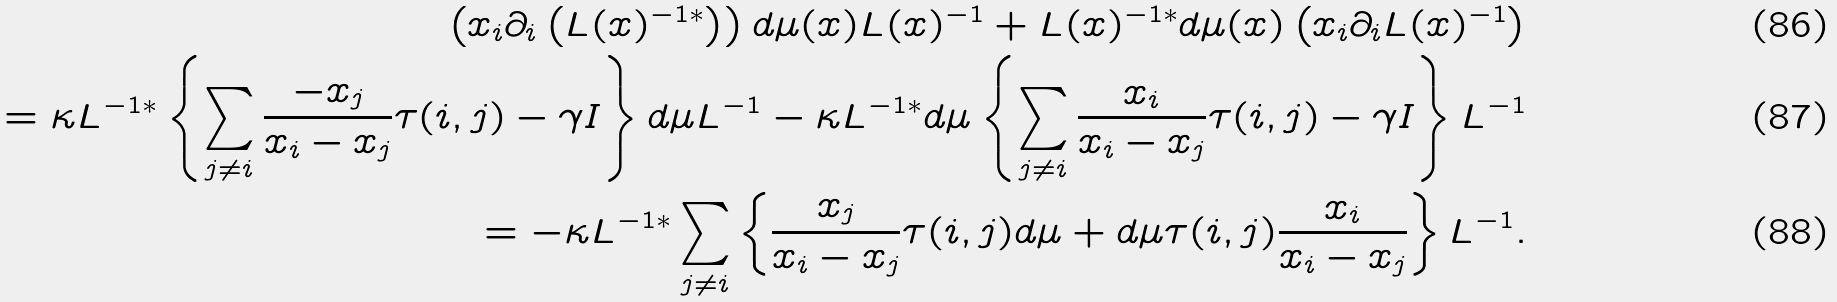Convert formula to latex. <formula><loc_0><loc_0><loc_500><loc_500>\left ( x _ { i } \partial _ { i } \left ( L ( x ) ^ { - 1 \ast } \right ) \right ) d \mu ( x ) L ( x ) ^ { - 1 } + L ( x ) ^ { - 1 \ast } d \mu ( x ) \left ( x _ { i } \partial _ { i } L ( x ) ^ { - 1 } \right ) \\ = \kappa L ^ { - 1 \ast } \left \{ \sum _ { j \neq i } \frac { - x _ { j } } { x _ { i } - x _ { j } } \tau ( i , j ) - \gamma I \right \} d \mu L ^ { - 1 } - \kappa L ^ { - 1 \ast } d \mu \left \{ \sum _ { j \neq i } \frac { x _ { i } } { x _ { i } - x _ { j } } \tau ( i , j ) - \gamma I \right \} L ^ { - 1 } \\ = - \kappa L ^ { - 1 \ast } \sum _ { j \neq i } \left \{ \frac { x _ { j } } { x _ { i } - x _ { j } } \tau ( i , j ) d \mu + d \mu \tau ( i , j ) \frac { x _ { i } } { x _ { i } - x _ { j } } \right \} L ^ { - 1 } .</formula> 